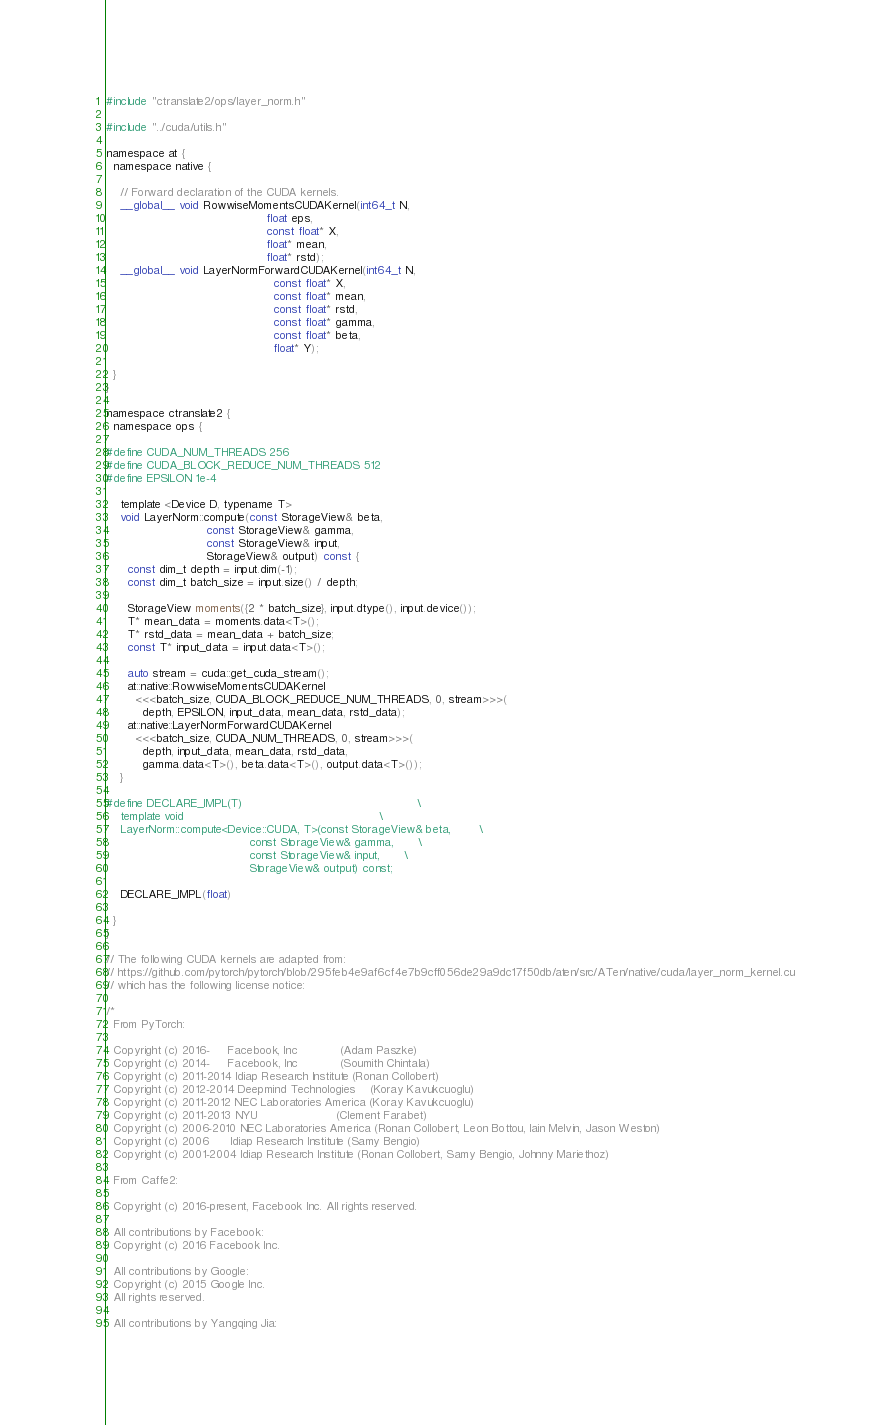<code> <loc_0><loc_0><loc_500><loc_500><_Cuda_>#include "ctranslate2/ops/layer_norm.h"

#include "../cuda/utils.h"

namespace at {
  namespace native {

    // Forward declaration of the CUDA kernels.
    __global__ void RowwiseMomentsCUDAKernel(int64_t N,
                                             float eps,
                                             const float* X,
                                             float* mean,
                                             float* rstd);
    __global__ void LayerNormForwardCUDAKernel(int64_t N,
                                               const float* X,
                                               const float* mean,
                                               const float* rstd,
                                               const float* gamma,
                                               const float* beta,
                                               float* Y);

  }
}

namespace ctranslate2 {
  namespace ops {

#define CUDA_NUM_THREADS 256
#define CUDA_BLOCK_REDUCE_NUM_THREADS 512
#define EPSILON 1e-4

    template <Device D, typename T>
    void LayerNorm::compute(const StorageView& beta,
                            const StorageView& gamma,
                            const StorageView& input,
                            StorageView& output) const {
      const dim_t depth = input.dim(-1);
      const dim_t batch_size = input.size() / depth;

      StorageView moments({2 * batch_size}, input.dtype(), input.device());
      T* mean_data = moments.data<T>();
      T* rstd_data = mean_data + batch_size;
      const T* input_data = input.data<T>();

      auto stream = cuda::get_cuda_stream();
      at::native::RowwiseMomentsCUDAKernel
        <<<batch_size, CUDA_BLOCK_REDUCE_NUM_THREADS, 0, stream>>>(
          depth, EPSILON, input_data, mean_data, rstd_data);
      at::native::LayerNormForwardCUDAKernel
        <<<batch_size, CUDA_NUM_THREADS, 0, stream>>>(
          depth, input_data, mean_data, rstd_data,
          gamma.data<T>(), beta.data<T>(), output.data<T>());
    }

#define DECLARE_IMPL(T)                                                 \
    template void                                                       \
    LayerNorm::compute<Device::CUDA, T>(const StorageView& beta,        \
                                        const StorageView& gamma,       \
                                        const StorageView& input,       \
                                        StorageView& output) const;

    DECLARE_IMPL(float)

  }
}

// The following CUDA kernels are adapted from:
// https://github.com/pytorch/pytorch/blob/295feb4e9af6cf4e7b9cff056de29a9dc17f50db/aten/src/ATen/native/cuda/layer_norm_kernel.cu
// which has the following license notice:

/*
  From PyTorch:

  Copyright (c) 2016-     Facebook, Inc            (Adam Paszke)
  Copyright (c) 2014-     Facebook, Inc            (Soumith Chintala)
  Copyright (c) 2011-2014 Idiap Research Institute (Ronan Collobert)
  Copyright (c) 2012-2014 Deepmind Technologies    (Koray Kavukcuoglu)
  Copyright (c) 2011-2012 NEC Laboratories America (Koray Kavukcuoglu)
  Copyright (c) 2011-2013 NYU                      (Clement Farabet)
  Copyright (c) 2006-2010 NEC Laboratories America (Ronan Collobert, Leon Bottou, Iain Melvin, Jason Weston)
  Copyright (c) 2006      Idiap Research Institute (Samy Bengio)
  Copyright (c) 2001-2004 Idiap Research Institute (Ronan Collobert, Samy Bengio, Johnny Mariethoz)

  From Caffe2:

  Copyright (c) 2016-present, Facebook Inc. All rights reserved.

  All contributions by Facebook:
  Copyright (c) 2016 Facebook Inc.

  All contributions by Google:
  Copyright (c) 2015 Google Inc.
  All rights reserved.

  All contributions by Yangqing Jia:</code> 